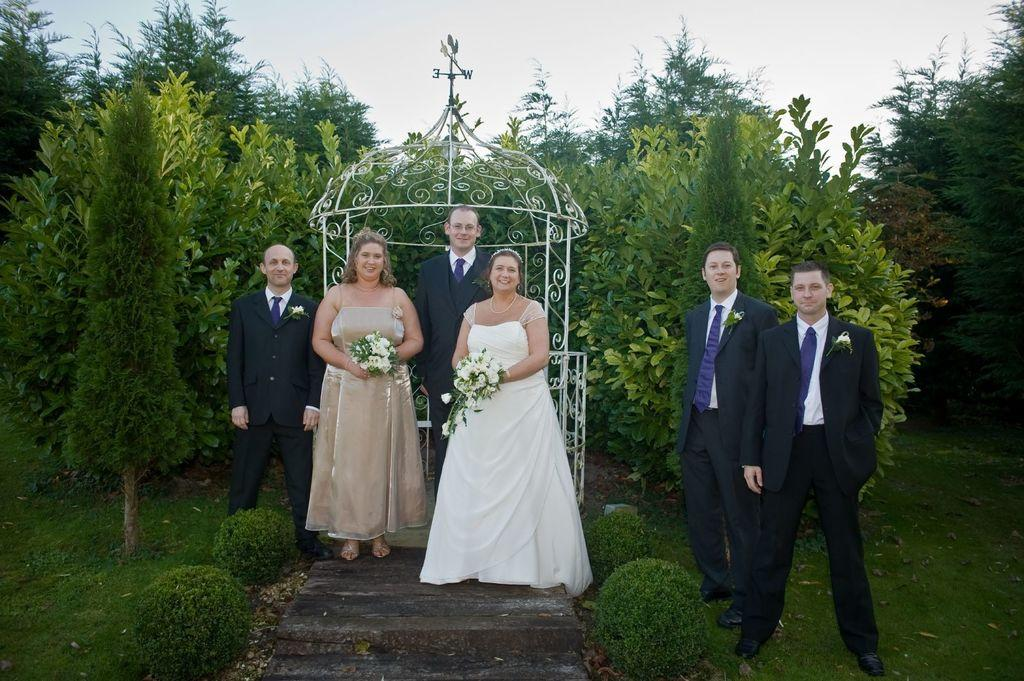What are the people in the center of the image doing? The people in the center of the image are standing, and the ladies are holding bouquets. What can be seen in the background of the image? There is a shed, trees, and the sky visible in the background of the image. What color is the crayon being used by the person in the image? There is no crayon present in the image. What type of hairstyle does the person in the image have? The image does not provide enough detail to determine the hairstyle of the person. What color is the eye of the person in the image? The image does not provide enough detail to determine the color of the person's eye. 